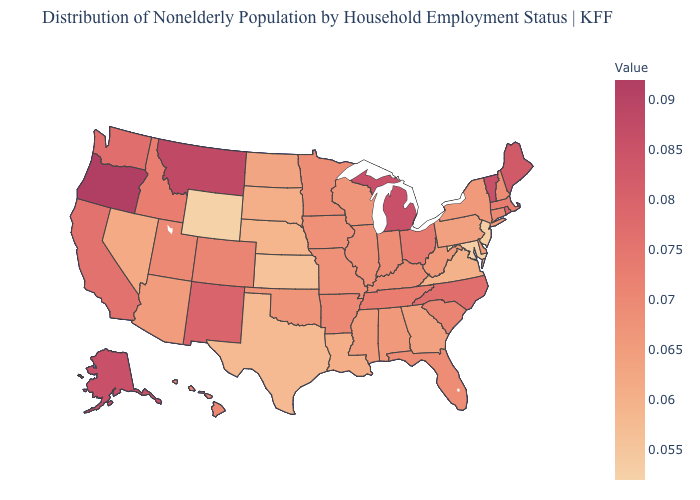Among the states that border Kentucky , which have the highest value?
Answer briefly. Ohio. Does the map have missing data?
Be succinct. No. Does Oregon have the highest value in the USA?
Concise answer only. Yes. Among the states that border Nevada , does Oregon have the highest value?
Keep it brief. Yes. 